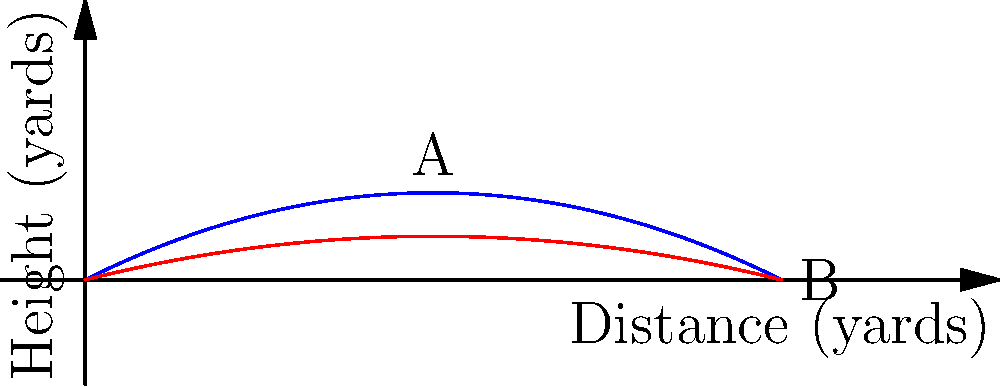In the diagram above, two football throwing techniques are represented: a spiral throw (blue) and a bullet pass (red). At which point does the spiral throw reach its maximum height, and how does this compare to the bullet pass at the same distance? To answer this question, we need to analyze the trajectories of both throws:

1. The spiral throw (blue curve) reaches its maximum height at point A, which appears to be around 5 yards in distance.

2. The bullet pass (red curve) has a flatter trajectory and doesn't reach its maximum height within the shown range.

3. At the 5-yard mark (point A):
   - The spiral throw is at its peak height, approximately 1.25 yards high.
   - The bullet pass is still rising but is lower, about 0.75 yards high.

4. The spiral throw allows for a higher arc, which can be useful for throwing over defenders, while the bullet pass maintains a lower, more direct path to the receiver.

5. The maximum height of the spiral throw occurs at approximately half the total distance shown (5 out of 10 yards), which is consistent with the parabolic nature of a football's trajectory when thrown.

6. The bullet pass, having a flatter trajectory, would likely reach its maximum height beyond the range shown in the diagram, making it more suitable for quick, short-distance passes.
Answer: Point A (5 yards); spiral throw is higher (1.25 yards) than bullet pass (0.75 yards) at this point. 